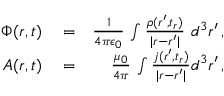<formula> <loc_0><loc_0><loc_500><loc_500>\begin{array} { r l r } { \Phi ( r , t ) } & = } & { \frac { 1 } { 4 \pi \epsilon _ { 0 } } \, \int \frac { \rho ( r ^ { \prime } , t _ { r } ) } { | r - r ^ { \prime } | } \, d ^ { 3 } r ^ { \prime } \, , } \\ { A ( r , t ) } & = } & { \frac { \mu _ { 0 } } { 4 \pi } \, \int \frac { j ( r ^ { \prime } , t _ { r } ) } { | r - r ^ { \prime } | } d ^ { 3 } r ^ { \prime } \, , } \end{array}</formula> 